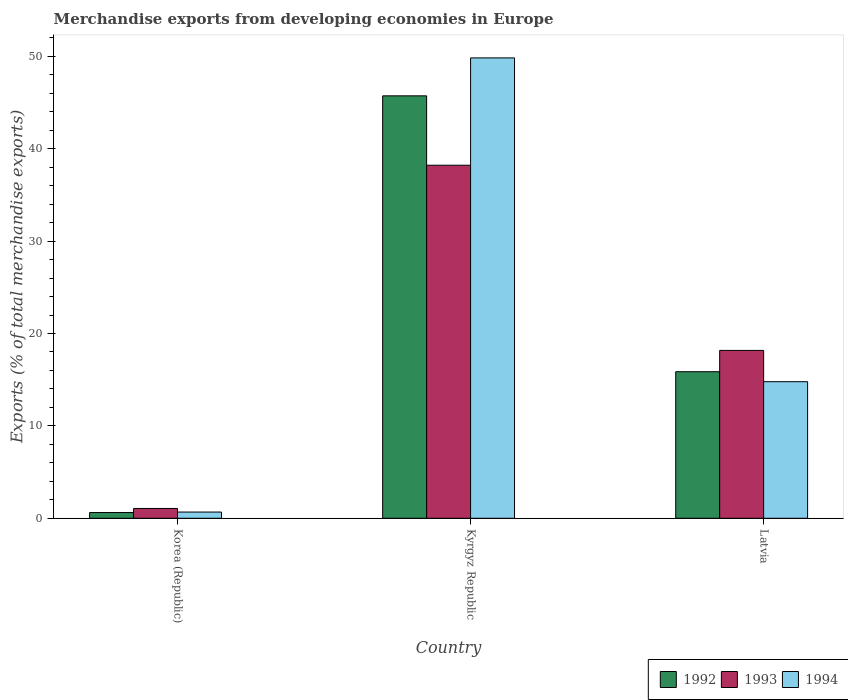Are the number of bars on each tick of the X-axis equal?
Give a very brief answer. Yes. How many bars are there on the 3rd tick from the left?
Offer a very short reply. 3. What is the label of the 2nd group of bars from the left?
Give a very brief answer. Kyrgyz Republic. In how many cases, is the number of bars for a given country not equal to the number of legend labels?
Provide a succinct answer. 0. What is the percentage of total merchandise exports in 1994 in Latvia?
Offer a very short reply. 14.79. Across all countries, what is the maximum percentage of total merchandise exports in 1993?
Provide a succinct answer. 38.22. Across all countries, what is the minimum percentage of total merchandise exports in 1992?
Your answer should be very brief. 0.62. In which country was the percentage of total merchandise exports in 1992 maximum?
Offer a very short reply. Kyrgyz Republic. What is the total percentage of total merchandise exports in 1994 in the graph?
Your answer should be very brief. 65.29. What is the difference between the percentage of total merchandise exports in 1993 in Korea (Republic) and that in Kyrgyz Republic?
Provide a succinct answer. -37.16. What is the difference between the percentage of total merchandise exports in 1992 in Korea (Republic) and the percentage of total merchandise exports in 1993 in Latvia?
Your response must be concise. -17.55. What is the average percentage of total merchandise exports in 1992 per country?
Your answer should be very brief. 20.74. What is the difference between the percentage of total merchandise exports of/in 1994 and percentage of total merchandise exports of/in 1992 in Korea (Republic)?
Offer a terse response. 0.05. What is the ratio of the percentage of total merchandise exports in 1992 in Korea (Republic) to that in Kyrgyz Republic?
Offer a very short reply. 0.01. Is the difference between the percentage of total merchandise exports in 1994 in Kyrgyz Republic and Latvia greater than the difference between the percentage of total merchandise exports in 1992 in Kyrgyz Republic and Latvia?
Ensure brevity in your answer.  Yes. What is the difference between the highest and the second highest percentage of total merchandise exports in 1993?
Offer a terse response. -17.11. What is the difference between the highest and the lowest percentage of total merchandise exports in 1993?
Keep it short and to the point. 37.16. In how many countries, is the percentage of total merchandise exports in 1994 greater than the average percentage of total merchandise exports in 1994 taken over all countries?
Give a very brief answer. 1. Is the sum of the percentage of total merchandise exports in 1994 in Korea (Republic) and Kyrgyz Republic greater than the maximum percentage of total merchandise exports in 1993 across all countries?
Give a very brief answer. Yes. What does the 3rd bar from the left in Kyrgyz Republic represents?
Offer a terse response. 1994. Are all the bars in the graph horizontal?
Offer a terse response. No. Are the values on the major ticks of Y-axis written in scientific E-notation?
Keep it short and to the point. No. Where does the legend appear in the graph?
Provide a succinct answer. Bottom right. What is the title of the graph?
Provide a short and direct response. Merchandise exports from developing economies in Europe. Does "1991" appear as one of the legend labels in the graph?
Ensure brevity in your answer.  No. What is the label or title of the X-axis?
Keep it short and to the point. Country. What is the label or title of the Y-axis?
Offer a very short reply. Exports (% of total merchandise exports). What is the Exports (% of total merchandise exports) in 1992 in Korea (Republic)?
Offer a very short reply. 0.62. What is the Exports (% of total merchandise exports) of 1993 in Korea (Republic)?
Your answer should be very brief. 1.06. What is the Exports (% of total merchandise exports) of 1994 in Korea (Republic)?
Your response must be concise. 0.67. What is the Exports (% of total merchandise exports) of 1992 in Kyrgyz Republic?
Your answer should be very brief. 45.73. What is the Exports (% of total merchandise exports) in 1993 in Kyrgyz Republic?
Provide a short and direct response. 38.22. What is the Exports (% of total merchandise exports) of 1994 in Kyrgyz Republic?
Keep it short and to the point. 49.84. What is the Exports (% of total merchandise exports) in 1992 in Latvia?
Your answer should be very brief. 15.87. What is the Exports (% of total merchandise exports) of 1993 in Latvia?
Your answer should be very brief. 18.17. What is the Exports (% of total merchandise exports) of 1994 in Latvia?
Your response must be concise. 14.79. Across all countries, what is the maximum Exports (% of total merchandise exports) in 1992?
Give a very brief answer. 45.73. Across all countries, what is the maximum Exports (% of total merchandise exports) in 1993?
Provide a succinct answer. 38.22. Across all countries, what is the maximum Exports (% of total merchandise exports) in 1994?
Your response must be concise. 49.84. Across all countries, what is the minimum Exports (% of total merchandise exports) in 1992?
Keep it short and to the point. 0.62. Across all countries, what is the minimum Exports (% of total merchandise exports) in 1993?
Give a very brief answer. 1.06. Across all countries, what is the minimum Exports (% of total merchandise exports) in 1994?
Your answer should be compact. 0.67. What is the total Exports (% of total merchandise exports) of 1992 in the graph?
Provide a short and direct response. 62.22. What is the total Exports (% of total merchandise exports) in 1993 in the graph?
Your answer should be very brief. 57.45. What is the total Exports (% of total merchandise exports) in 1994 in the graph?
Provide a short and direct response. 65.29. What is the difference between the Exports (% of total merchandise exports) of 1992 in Korea (Republic) and that in Kyrgyz Republic?
Provide a short and direct response. -45.11. What is the difference between the Exports (% of total merchandise exports) of 1993 in Korea (Republic) and that in Kyrgyz Republic?
Your response must be concise. -37.16. What is the difference between the Exports (% of total merchandise exports) in 1994 in Korea (Republic) and that in Kyrgyz Republic?
Ensure brevity in your answer.  -49.16. What is the difference between the Exports (% of total merchandise exports) in 1992 in Korea (Republic) and that in Latvia?
Ensure brevity in your answer.  -15.25. What is the difference between the Exports (% of total merchandise exports) in 1993 in Korea (Republic) and that in Latvia?
Keep it short and to the point. -17.11. What is the difference between the Exports (% of total merchandise exports) of 1994 in Korea (Republic) and that in Latvia?
Provide a short and direct response. -14.11. What is the difference between the Exports (% of total merchandise exports) of 1992 in Kyrgyz Republic and that in Latvia?
Provide a succinct answer. 29.86. What is the difference between the Exports (% of total merchandise exports) of 1993 in Kyrgyz Republic and that in Latvia?
Offer a very short reply. 20.04. What is the difference between the Exports (% of total merchandise exports) in 1994 in Kyrgyz Republic and that in Latvia?
Offer a terse response. 35.05. What is the difference between the Exports (% of total merchandise exports) in 1992 in Korea (Republic) and the Exports (% of total merchandise exports) in 1993 in Kyrgyz Republic?
Provide a succinct answer. -37.6. What is the difference between the Exports (% of total merchandise exports) in 1992 in Korea (Republic) and the Exports (% of total merchandise exports) in 1994 in Kyrgyz Republic?
Keep it short and to the point. -49.22. What is the difference between the Exports (% of total merchandise exports) in 1993 in Korea (Republic) and the Exports (% of total merchandise exports) in 1994 in Kyrgyz Republic?
Offer a terse response. -48.77. What is the difference between the Exports (% of total merchandise exports) of 1992 in Korea (Republic) and the Exports (% of total merchandise exports) of 1993 in Latvia?
Your answer should be compact. -17.55. What is the difference between the Exports (% of total merchandise exports) in 1992 in Korea (Republic) and the Exports (% of total merchandise exports) in 1994 in Latvia?
Provide a short and direct response. -14.16. What is the difference between the Exports (% of total merchandise exports) of 1993 in Korea (Republic) and the Exports (% of total merchandise exports) of 1994 in Latvia?
Keep it short and to the point. -13.72. What is the difference between the Exports (% of total merchandise exports) of 1992 in Kyrgyz Republic and the Exports (% of total merchandise exports) of 1993 in Latvia?
Your answer should be compact. 27.56. What is the difference between the Exports (% of total merchandise exports) in 1992 in Kyrgyz Republic and the Exports (% of total merchandise exports) in 1994 in Latvia?
Make the answer very short. 30.94. What is the difference between the Exports (% of total merchandise exports) in 1993 in Kyrgyz Republic and the Exports (% of total merchandise exports) in 1994 in Latvia?
Your response must be concise. 23.43. What is the average Exports (% of total merchandise exports) in 1992 per country?
Ensure brevity in your answer.  20.74. What is the average Exports (% of total merchandise exports) in 1993 per country?
Provide a short and direct response. 19.15. What is the average Exports (% of total merchandise exports) of 1994 per country?
Keep it short and to the point. 21.76. What is the difference between the Exports (% of total merchandise exports) in 1992 and Exports (% of total merchandise exports) in 1993 in Korea (Republic)?
Offer a very short reply. -0.44. What is the difference between the Exports (% of total merchandise exports) in 1992 and Exports (% of total merchandise exports) in 1994 in Korea (Republic)?
Ensure brevity in your answer.  -0.05. What is the difference between the Exports (% of total merchandise exports) of 1993 and Exports (% of total merchandise exports) of 1994 in Korea (Republic)?
Your answer should be compact. 0.39. What is the difference between the Exports (% of total merchandise exports) of 1992 and Exports (% of total merchandise exports) of 1993 in Kyrgyz Republic?
Provide a succinct answer. 7.51. What is the difference between the Exports (% of total merchandise exports) in 1992 and Exports (% of total merchandise exports) in 1994 in Kyrgyz Republic?
Provide a succinct answer. -4.11. What is the difference between the Exports (% of total merchandise exports) in 1993 and Exports (% of total merchandise exports) in 1994 in Kyrgyz Republic?
Offer a very short reply. -11.62. What is the difference between the Exports (% of total merchandise exports) in 1992 and Exports (% of total merchandise exports) in 1993 in Latvia?
Your response must be concise. -2.31. What is the difference between the Exports (% of total merchandise exports) of 1992 and Exports (% of total merchandise exports) of 1994 in Latvia?
Ensure brevity in your answer.  1.08. What is the difference between the Exports (% of total merchandise exports) of 1993 and Exports (% of total merchandise exports) of 1994 in Latvia?
Give a very brief answer. 3.39. What is the ratio of the Exports (% of total merchandise exports) of 1992 in Korea (Republic) to that in Kyrgyz Republic?
Keep it short and to the point. 0.01. What is the ratio of the Exports (% of total merchandise exports) of 1993 in Korea (Republic) to that in Kyrgyz Republic?
Provide a succinct answer. 0.03. What is the ratio of the Exports (% of total merchandise exports) of 1994 in Korea (Republic) to that in Kyrgyz Republic?
Give a very brief answer. 0.01. What is the ratio of the Exports (% of total merchandise exports) in 1992 in Korea (Republic) to that in Latvia?
Give a very brief answer. 0.04. What is the ratio of the Exports (% of total merchandise exports) in 1993 in Korea (Republic) to that in Latvia?
Your response must be concise. 0.06. What is the ratio of the Exports (% of total merchandise exports) in 1994 in Korea (Republic) to that in Latvia?
Offer a very short reply. 0.05. What is the ratio of the Exports (% of total merchandise exports) in 1992 in Kyrgyz Republic to that in Latvia?
Offer a terse response. 2.88. What is the ratio of the Exports (% of total merchandise exports) of 1993 in Kyrgyz Republic to that in Latvia?
Offer a very short reply. 2.1. What is the ratio of the Exports (% of total merchandise exports) of 1994 in Kyrgyz Republic to that in Latvia?
Make the answer very short. 3.37. What is the difference between the highest and the second highest Exports (% of total merchandise exports) in 1992?
Offer a very short reply. 29.86. What is the difference between the highest and the second highest Exports (% of total merchandise exports) in 1993?
Offer a very short reply. 20.04. What is the difference between the highest and the second highest Exports (% of total merchandise exports) in 1994?
Offer a very short reply. 35.05. What is the difference between the highest and the lowest Exports (% of total merchandise exports) of 1992?
Make the answer very short. 45.11. What is the difference between the highest and the lowest Exports (% of total merchandise exports) of 1993?
Your answer should be compact. 37.16. What is the difference between the highest and the lowest Exports (% of total merchandise exports) in 1994?
Offer a very short reply. 49.16. 